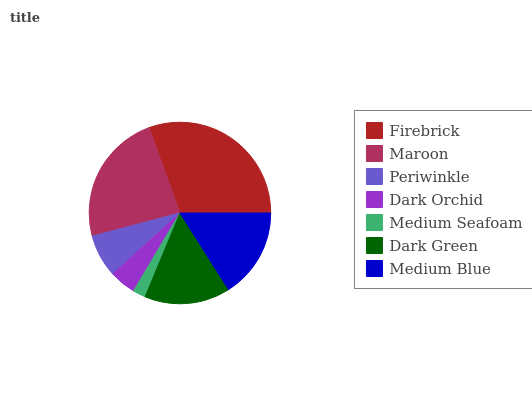Is Medium Seafoam the minimum?
Answer yes or no. Yes. Is Firebrick the maximum?
Answer yes or no. Yes. Is Maroon the minimum?
Answer yes or no. No. Is Maroon the maximum?
Answer yes or no. No. Is Firebrick greater than Maroon?
Answer yes or no. Yes. Is Maroon less than Firebrick?
Answer yes or no. Yes. Is Maroon greater than Firebrick?
Answer yes or no. No. Is Firebrick less than Maroon?
Answer yes or no. No. Is Dark Green the high median?
Answer yes or no. Yes. Is Dark Green the low median?
Answer yes or no. Yes. Is Dark Orchid the high median?
Answer yes or no. No. Is Medium Seafoam the low median?
Answer yes or no. No. 